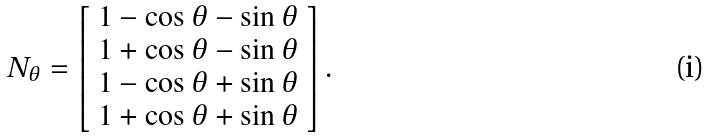Convert formula to latex. <formula><loc_0><loc_0><loc_500><loc_500>N _ { \theta } = \left [ \begin{array} { c } 1 - \cos \theta - \sin \theta \\ 1 + \cos \theta - \sin \theta \\ 1 - \cos \theta + \sin \theta \\ 1 + \cos \theta + \sin \theta \\ \end{array} \right ] .</formula> 